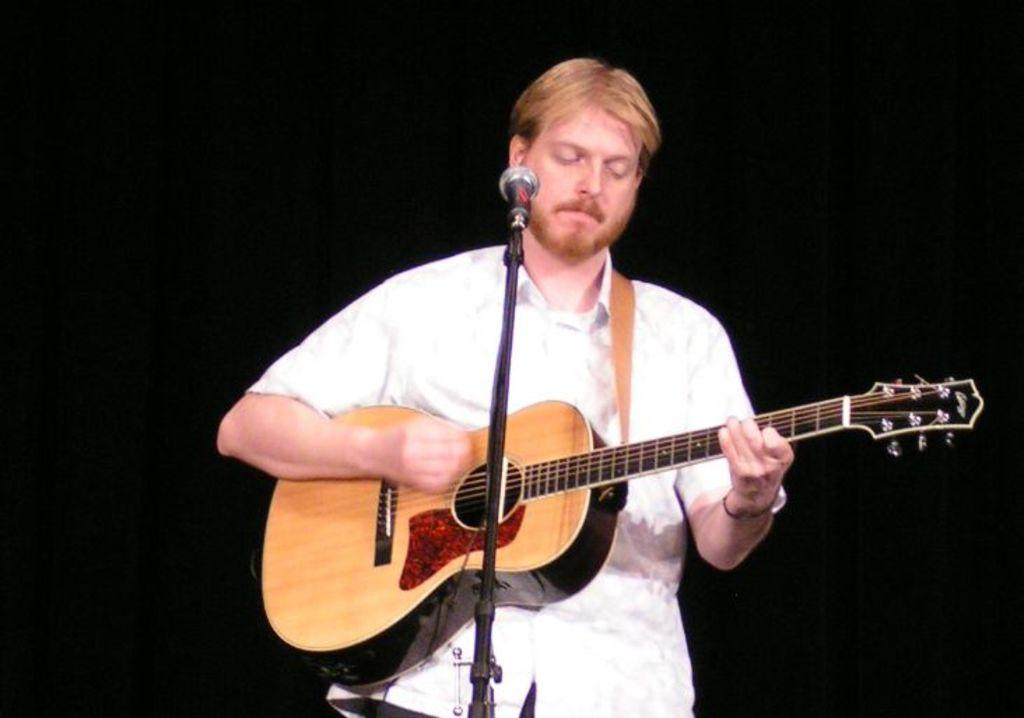What is the person in the image doing? The person is playing a guitar. What object is in front of the person? There is a microphone in front of the person. Can you see any tents in the image? There is no tent present in the image. What type of fowl is perched on the guitar in the image? There is no fowl present in the image, and the guitar is being played by the person. 